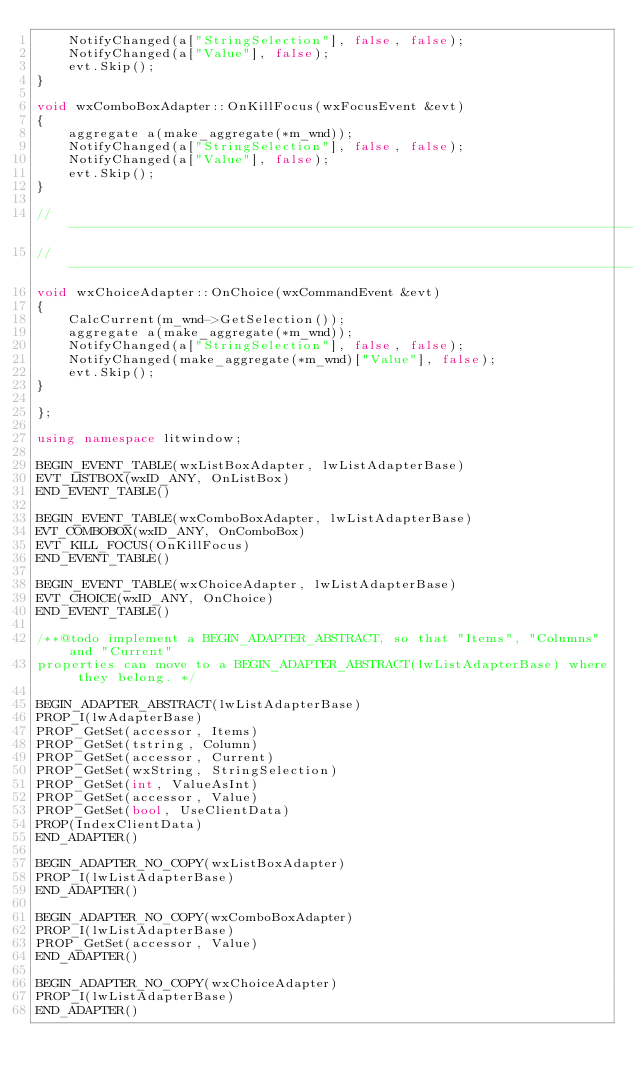<code> <loc_0><loc_0><loc_500><loc_500><_C++_>	NotifyChanged(a["StringSelection"], false, false);
	NotifyChanged(a["Value"], false);
	evt.Skip();
}

void wxComboBoxAdapter::OnKillFocus(wxFocusEvent &evt)
{
	aggregate a(make_aggregate(*m_wnd));
	NotifyChanged(a["StringSelection"], false, false);
	NotifyChanged(a["Value"], false);
	evt.Skip();
}

//-----------------------------------------------------------------------------------------------------------//
//-----------------------------------------------------------------------------------------------------------//
void wxChoiceAdapter::OnChoice(wxCommandEvent &evt)
{
	CalcCurrent(m_wnd->GetSelection());
	aggregate a(make_aggregate(*m_wnd));
	NotifyChanged(a["StringSelection"], false, false);
	NotifyChanged(make_aggregate(*m_wnd)["Value"], false);
	evt.Skip();
}

};

using namespace litwindow;

BEGIN_EVENT_TABLE(wxListBoxAdapter, lwListAdapterBase)
EVT_LISTBOX(wxID_ANY, OnListBox)
END_EVENT_TABLE()

BEGIN_EVENT_TABLE(wxComboBoxAdapter, lwListAdapterBase)
EVT_COMBOBOX(wxID_ANY, OnComboBox)
EVT_KILL_FOCUS(OnKillFocus)
END_EVENT_TABLE()

BEGIN_EVENT_TABLE(wxChoiceAdapter, lwListAdapterBase)
EVT_CHOICE(wxID_ANY, OnChoice)
END_EVENT_TABLE()

/**@todo implement a BEGIN_ADAPTER_ABSTRACT, so that "Items", "Columns" and "Current"
properties can move to a BEGIN_ADAPTER_ABSTRACT(lwListAdapterBase) where they belong. */

BEGIN_ADAPTER_ABSTRACT(lwListAdapterBase)
PROP_I(lwAdapterBase)
PROP_GetSet(accessor, Items)
PROP_GetSet(tstring, Column)
PROP_GetSet(accessor, Current)
PROP_GetSet(wxString, StringSelection)
PROP_GetSet(int, ValueAsInt)
PROP_GetSet(accessor, Value)
PROP_GetSet(bool, UseClientData)
PROP(IndexClientData)
END_ADAPTER()

BEGIN_ADAPTER_NO_COPY(wxListBoxAdapter)
PROP_I(lwListAdapterBase)
END_ADAPTER()

BEGIN_ADAPTER_NO_COPY(wxComboBoxAdapter)
PROP_I(lwListAdapterBase)
PROP_GetSet(accessor, Value)
END_ADAPTER()

BEGIN_ADAPTER_NO_COPY(wxChoiceAdapter)
PROP_I(lwListAdapterBase)
END_ADAPTER()
</code> 